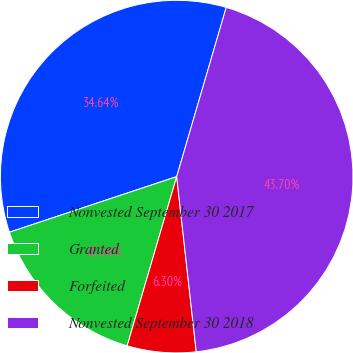<chart> <loc_0><loc_0><loc_500><loc_500><pie_chart><fcel>Nonvested September 30 2017<fcel>Granted<fcel>Forfeited<fcel>Nonvested September 30 2018<nl><fcel>34.64%<fcel>15.36%<fcel>6.3%<fcel>43.7%<nl></chart> 